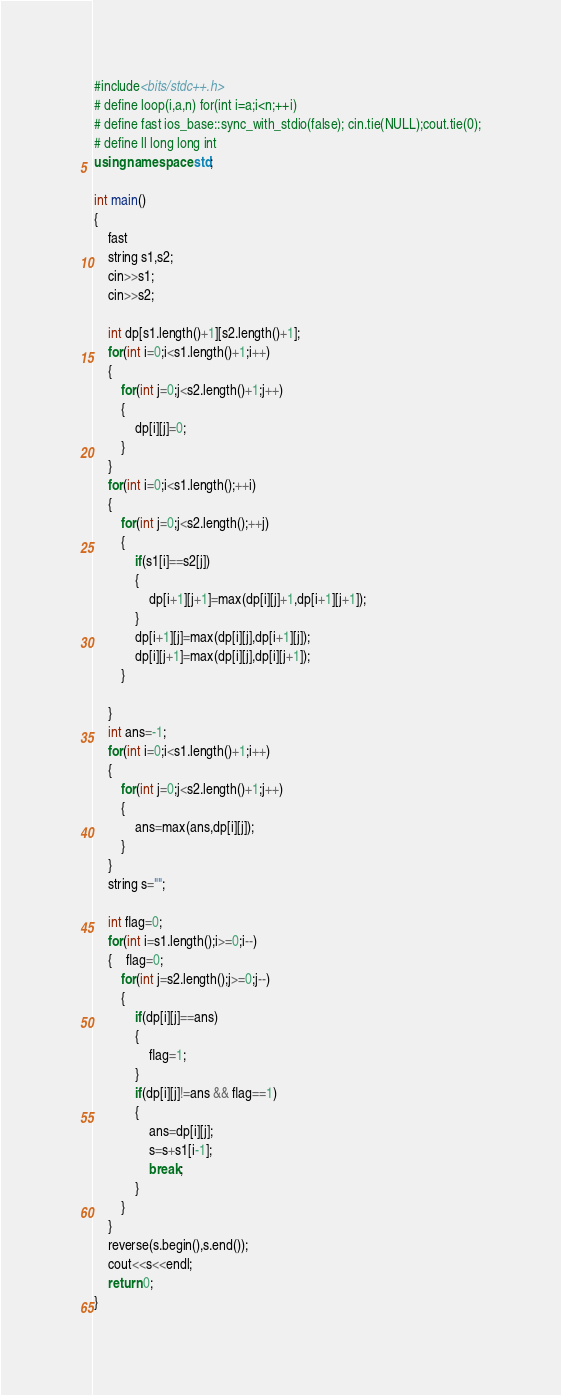Convert code to text. <code><loc_0><loc_0><loc_500><loc_500><_C++_>#include<bits/stdc++.h>
# define loop(i,a,n) for(int i=a;i<n;++i)
# define fast ios_base::sync_with_stdio(false); cin.tie(NULL);cout.tie(0);
# define ll long long int 
using namespace std;

int main()
{
    fast
    string s1,s2;
    cin>>s1;
    cin>>s2;
   
    int dp[s1.length()+1][s2.length()+1];
    for(int i=0;i<s1.length()+1;i++)
    {
        for(int j=0;j<s2.length()+1;j++)
        {
            dp[i][j]=0;
        }
    }
    for(int i=0;i<s1.length();++i)
    {
        for(int j=0;j<s2.length();++j)
        {
            if(s1[i]==s2[j])
            {
                dp[i+1][j+1]=max(dp[i][j]+1,dp[i+1][j+1]);
            }
            dp[i+1][j]=max(dp[i][j],dp[i+1][j]);
            dp[i][j+1]=max(dp[i][j],dp[i][j+1]);
        }
        
    }
    int ans=-1;
    for(int i=0;i<s1.length()+1;i++)
    {
        for(int j=0;j<s2.length()+1;j++)
        {
            ans=max(ans,dp[i][j]);
        }
    }
    string s="";
   
    int flag=0;
    for(int i=s1.length();i>=0;i--)
    {	flag=0;
        for(int j=s2.length();j>=0;j--)
        {
            if(dp[i][j]==ans)
            {
            	flag=1;
            }
            if(dp[i][j]!=ans && flag==1)
            {
            	ans=dp[i][j];
            	s=s+s1[i-1];
            	break;
            }
        }
    }
    reverse(s.begin(),s.end());
    cout<<s<<endl;
    return 0;
}</code> 